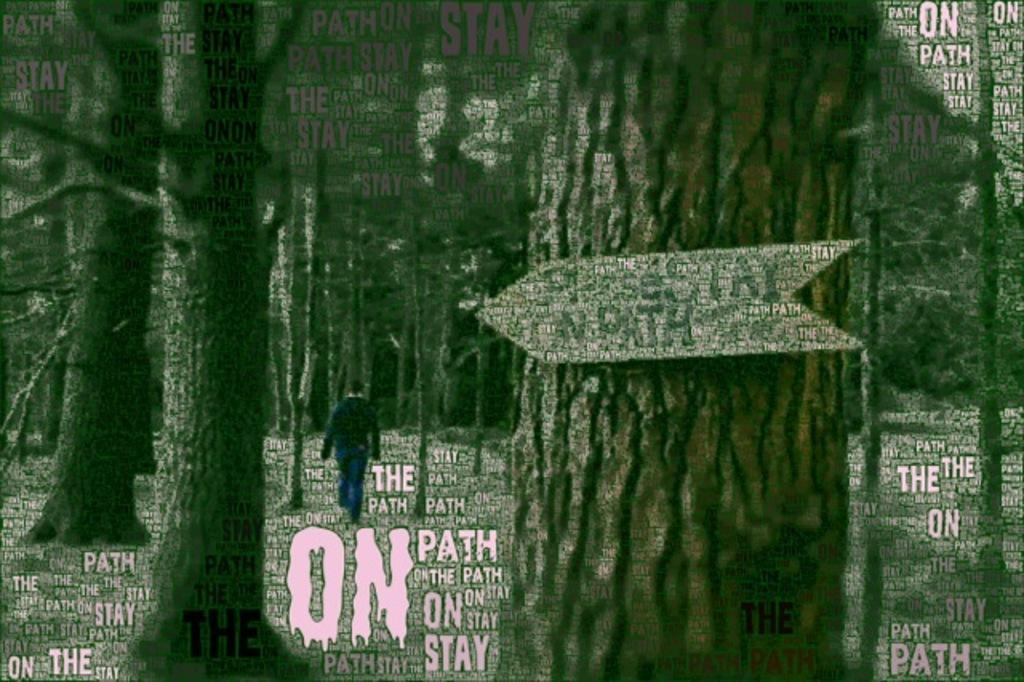What type of natural elements can be seen in the image? The image contains trees. What is the person in the image doing? There is a person walking in the center of the image. Are there any words or letters visible in the image? Yes, there is text visible in the image. What type of guitar is the person playing in the image? There is no guitar present in the image; the person is walking. Can you tell me how many mothers are visible in the image? There is no mother visible in the image; it only shows a person walking and trees. 